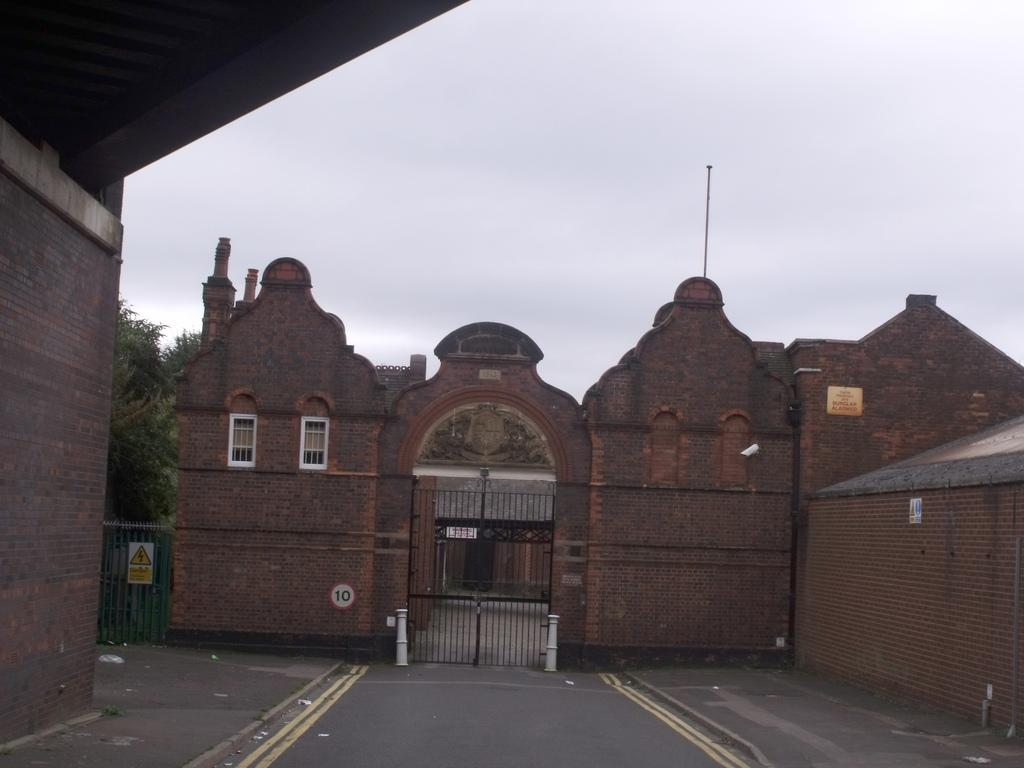What type of structure is present in the image? There is a building in the image. What can be seen behind the building? There is a tree behind the building. What part of the building is visible in the image? The roof of the building is visible. What is visible in the sky in the image? There are clouds in the sky, and the sky is visible at the top of the image. What type of apparatus is being used by the team in the image? There is no apparatus or team present in the image; it features a building with a tree behind it, a visible roof, and clouds in the sky. 